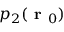Convert formula to latex. <formula><loc_0><loc_0><loc_500><loc_500>p _ { 2 } ( r _ { 0 } )</formula> 